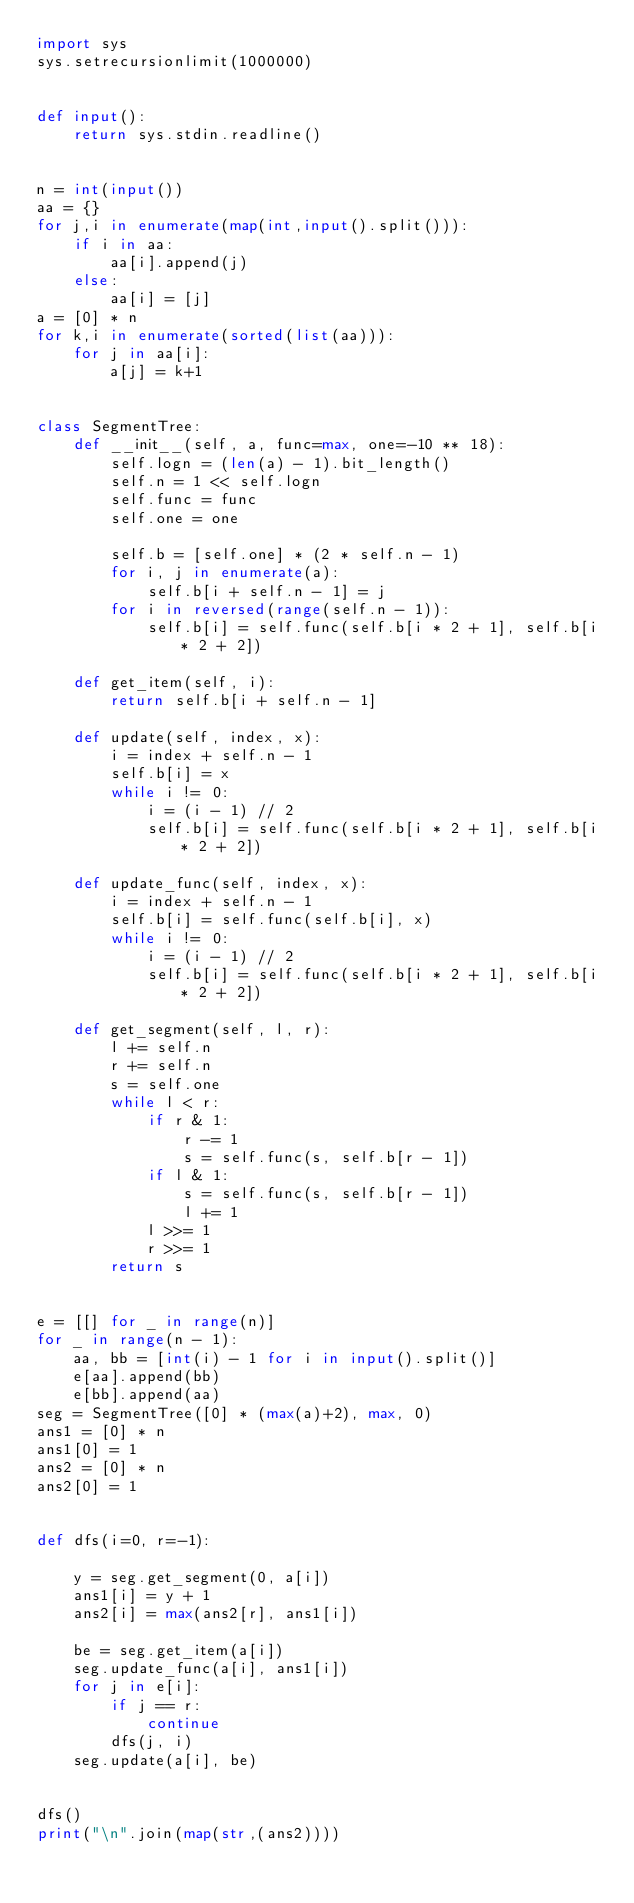Convert code to text. <code><loc_0><loc_0><loc_500><loc_500><_Python_>import sys
sys.setrecursionlimit(1000000)


def input():
    return sys.stdin.readline()


n = int(input())
aa = {}
for j,i in enumerate(map(int,input().split())):
    if i in aa:
        aa[i].append(j)
    else:
        aa[i] = [j]
a = [0] * n
for k,i in enumerate(sorted(list(aa))):
    for j in aa[i]:
        a[j] = k+1


class SegmentTree:
    def __init__(self, a, func=max, one=-10 ** 18):
        self.logn = (len(a) - 1).bit_length()
        self.n = 1 << self.logn
        self.func = func
        self.one = one

        self.b = [self.one] * (2 * self.n - 1)
        for i, j in enumerate(a):
            self.b[i + self.n - 1] = j
        for i in reversed(range(self.n - 1)):
            self.b[i] = self.func(self.b[i * 2 + 1], self.b[i * 2 + 2])

    def get_item(self, i):
        return self.b[i + self.n - 1]

    def update(self, index, x):
        i = index + self.n - 1
        self.b[i] = x
        while i != 0:
            i = (i - 1) // 2
            self.b[i] = self.func(self.b[i * 2 + 1], self.b[i * 2 + 2])

    def update_func(self, index, x):
        i = index + self.n - 1
        self.b[i] = self.func(self.b[i], x)
        while i != 0:
            i = (i - 1) // 2
            self.b[i] = self.func(self.b[i * 2 + 1], self.b[i * 2 + 2])

    def get_segment(self, l, r):
        l += self.n
        r += self.n
        s = self.one
        while l < r:
            if r & 1:
                r -= 1
                s = self.func(s, self.b[r - 1])
            if l & 1:
                s = self.func(s, self.b[r - 1])
                l += 1
            l >>= 1
            r >>= 1
        return s


e = [[] for _ in range(n)]
for _ in range(n - 1):
    aa, bb = [int(i) - 1 for i in input().split()]
    e[aa].append(bb)
    e[bb].append(aa)
seg = SegmentTree([0] * (max(a)+2), max, 0)
ans1 = [0] * n
ans1[0] = 1
ans2 = [0] * n
ans2[0] = 1


def dfs(i=0, r=-1):

    y = seg.get_segment(0, a[i])
    ans1[i] = y + 1
    ans2[i] = max(ans2[r], ans1[i])

    be = seg.get_item(a[i])
    seg.update_func(a[i], ans1[i])
    for j in e[i]:
        if j == r:
            continue
        dfs(j, i)
    seg.update(a[i], be)


dfs()
print("\n".join(map(str,(ans2))))
</code> 